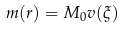<formula> <loc_0><loc_0><loc_500><loc_500>m ( r ) = M _ { 0 } v ( \xi )</formula> 